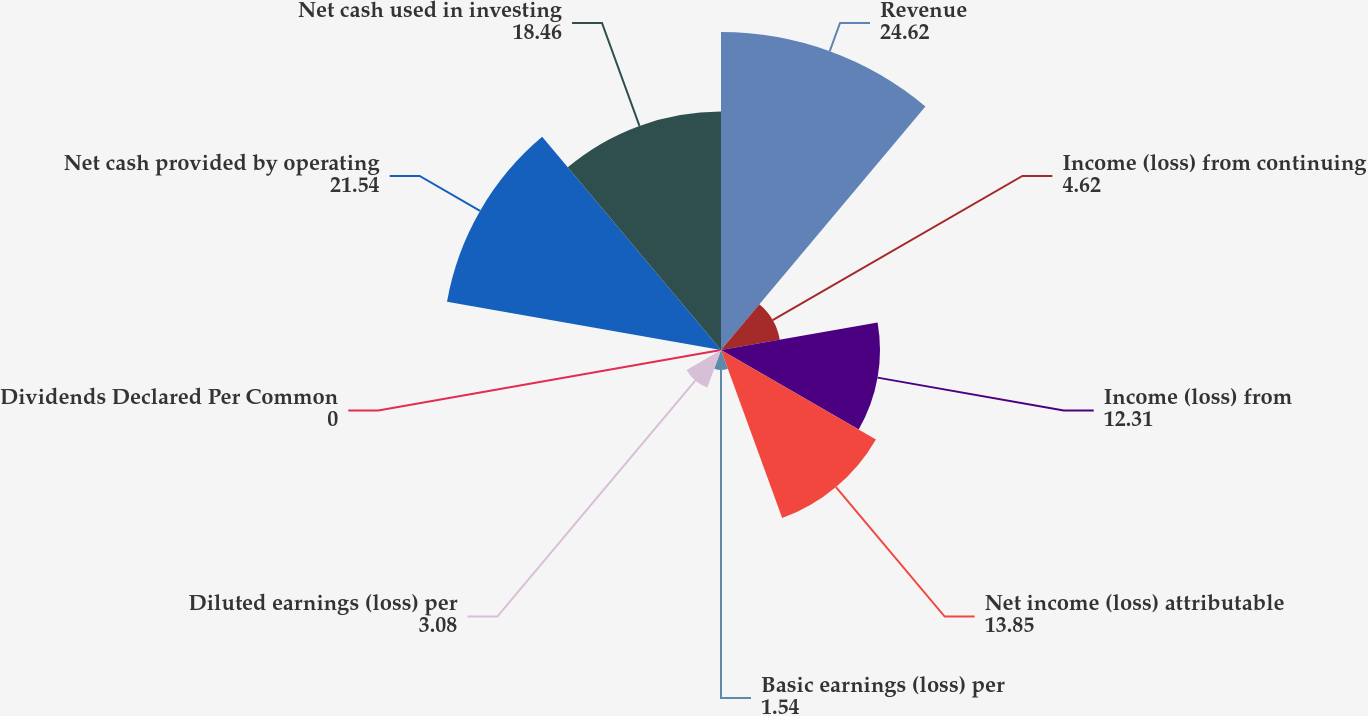Convert chart. <chart><loc_0><loc_0><loc_500><loc_500><pie_chart><fcel>Revenue<fcel>Income (loss) from continuing<fcel>Income (loss) from<fcel>Net income (loss) attributable<fcel>Basic earnings (loss) per<fcel>Diluted earnings (loss) per<fcel>Dividends Declared Per Common<fcel>Net cash provided by operating<fcel>Net cash used in investing<nl><fcel>24.62%<fcel>4.62%<fcel>12.31%<fcel>13.85%<fcel>1.54%<fcel>3.08%<fcel>0.0%<fcel>21.54%<fcel>18.46%<nl></chart> 